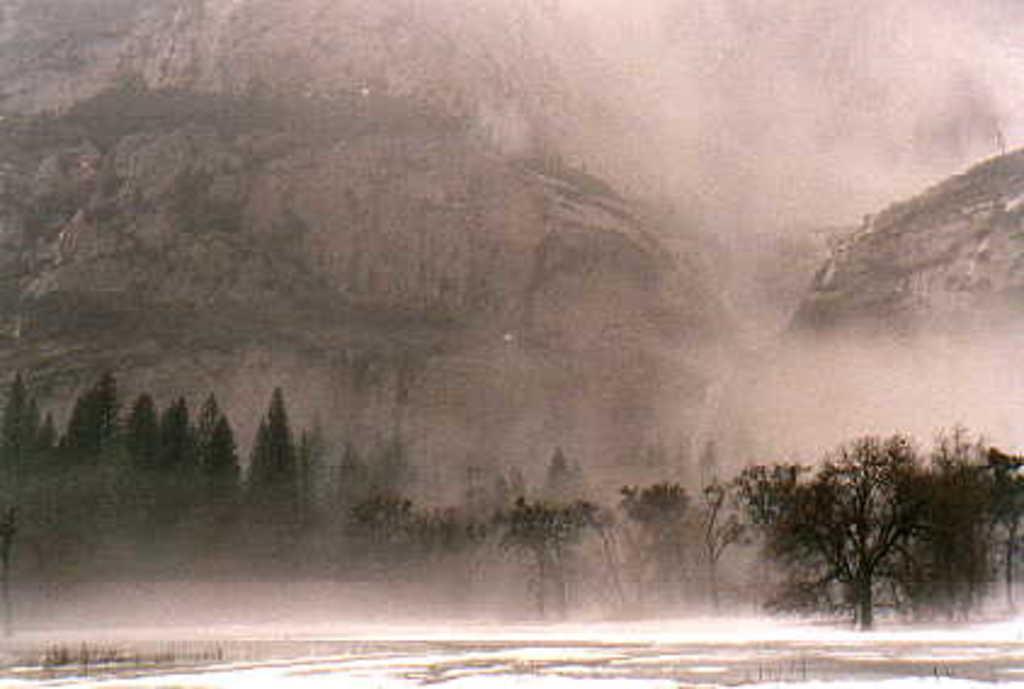Can you describe this image briefly? This is a black and white picture. In the middle of the picture, we see the trees. In the background, we see the hills. It might be raining. This picture is blurred in the background. 